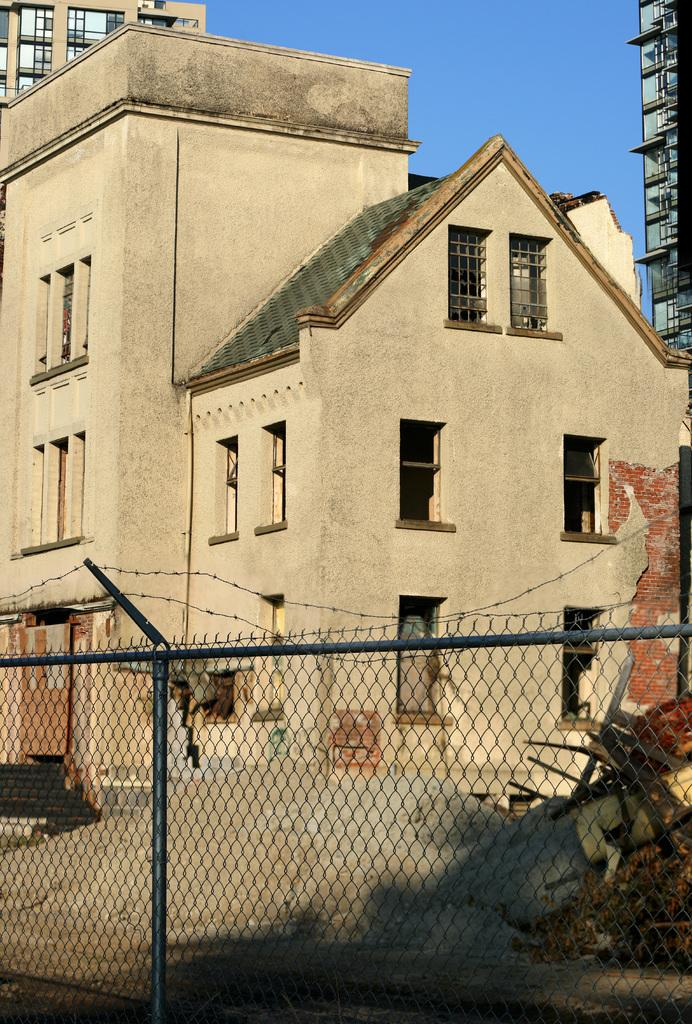What type of structures can be seen in the image? There are buildings in the image. What type of terrain is visible in the image? There is sand visible in the image. What objects are present on the ground in the image? There are objects on the ground in the image. What separates the buildings from the sand in the image? There is a fence in front of the building. What can be seen in the background of the image? The sky is visible in the background of the image. How many tickets are visible in the image? There are no tickets present in the image. What color is the string tied to the fence in the image? There is no string tied to the fence in the image. 